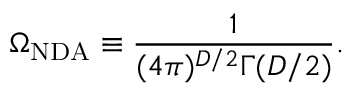Convert formula to latex. <formula><loc_0><loc_0><loc_500><loc_500>\Omega _ { N D A } \equiv \frac { 1 } { ( 4 \pi ) ^ { D / 2 } \Gamma ( D / 2 ) } .</formula> 